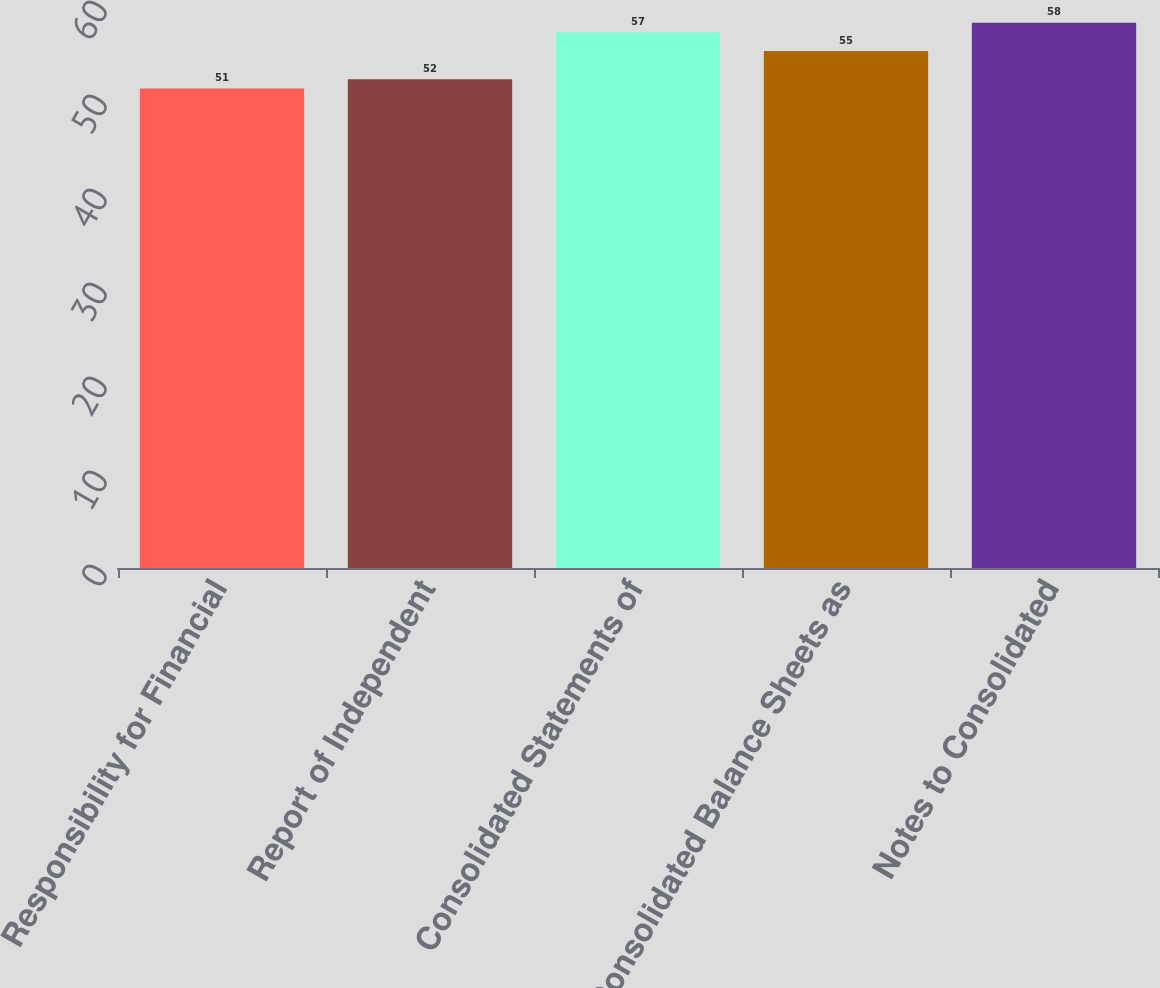<chart> <loc_0><loc_0><loc_500><loc_500><bar_chart><fcel>Responsibility for Financial<fcel>Report of Independent<fcel>Consolidated Statements of<fcel>Consolidated Balance Sheets as<fcel>Notes to Consolidated<nl><fcel>51<fcel>52<fcel>57<fcel>55<fcel>58<nl></chart> 